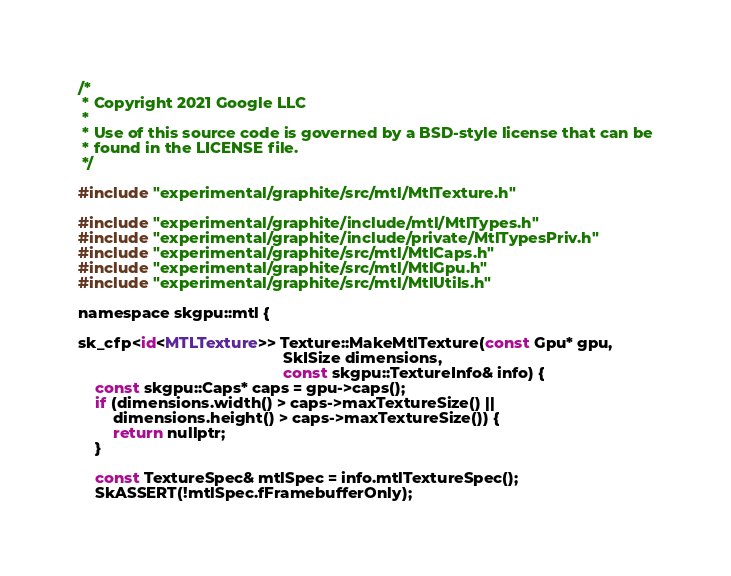<code> <loc_0><loc_0><loc_500><loc_500><_ObjectiveC_>/*
 * Copyright 2021 Google LLC
 *
 * Use of this source code is governed by a BSD-style license that can be
 * found in the LICENSE file.
 */

#include "experimental/graphite/src/mtl/MtlTexture.h"

#include "experimental/graphite/include/mtl/MtlTypes.h"
#include "experimental/graphite/include/private/MtlTypesPriv.h"
#include "experimental/graphite/src/mtl/MtlCaps.h"
#include "experimental/graphite/src/mtl/MtlGpu.h"
#include "experimental/graphite/src/mtl/MtlUtils.h"

namespace skgpu::mtl {

sk_cfp<id<MTLTexture>> Texture::MakeMtlTexture(const Gpu* gpu,
                                               SkISize dimensions,
                                               const skgpu::TextureInfo& info) {
    const skgpu::Caps* caps = gpu->caps();
    if (dimensions.width() > caps->maxTextureSize() ||
        dimensions.height() > caps->maxTextureSize()) {
        return nullptr;
    }

    const TextureSpec& mtlSpec = info.mtlTextureSpec();
    SkASSERT(!mtlSpec.fFramebufferOnly);
</code> 